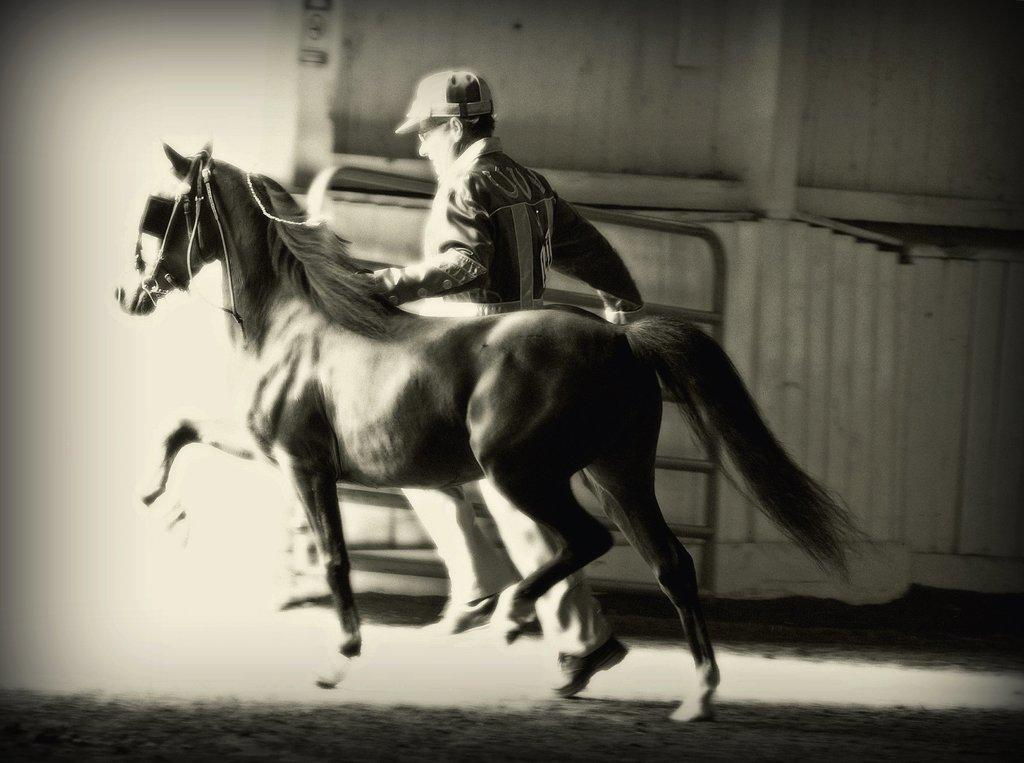Who is present in the image? There is a man in the image. What animal is also present in the image? There is a horse in the image. What are the man and the horse doing in the image? The man and the horse are running in the image. Where is the action taking place? The action is taking place inside a shed. What type of vegetable is being protested during the voyage in the image? There is no vegetable, protest, or voyage present in the image. The image features a man and a horse running inside a shed. 